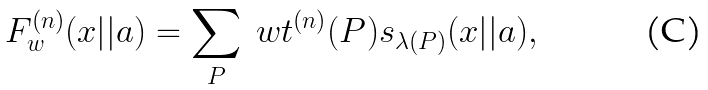<formula> <loc_0><loc_0><loc_500><loc_500>F ^ { ( n ) } _ { w } ( x | | a ) = \sum _ { P } \ w t ^ { ( n ) } ( P ) s _ { \lambda ( P ) } ( x | | a ) ,</formula> 